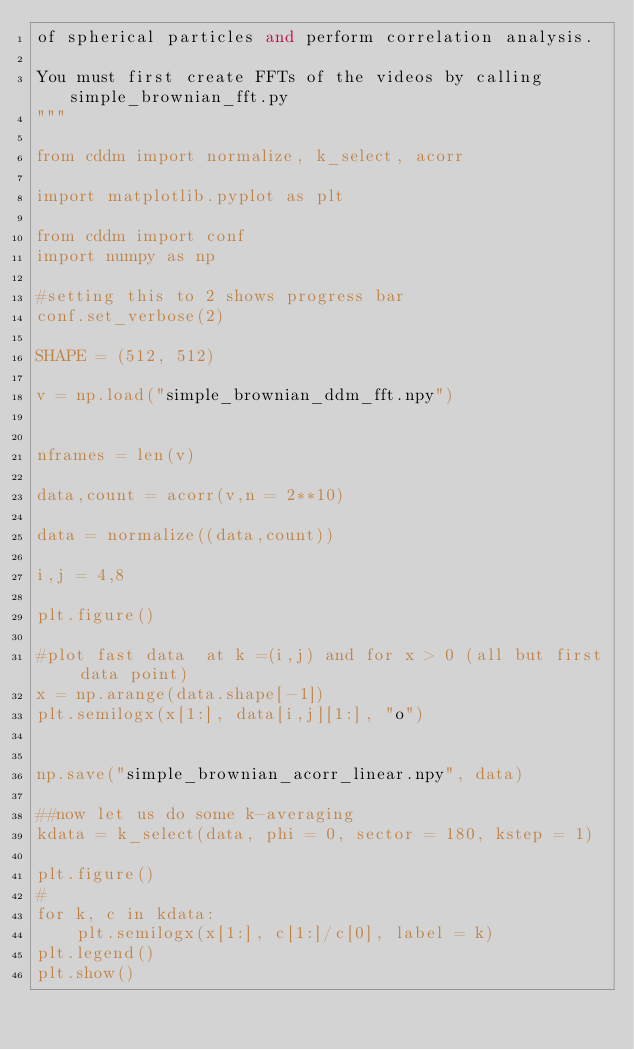Convert code to text. <code><loc_0><loc_0><loc_500><loc_500><_Python_>of spherical particles and perform correlation analysis.

You must first create FFTs of the videos by calling simple_brownian_fft.py
"""

from cddm import normalize, k_select, acorr

import matplotlib.pyplot as plt

from cddm import conf
import numpy as np

#setting this to 2 shows progress bar
conf.set_verbose(2)

SHAPE = (512, 512)

v = np.load("simple_brownian_ddm_fft.npy")


nframes = len(v)

data,count = acorr(v,n = 2**10)

data = normalize((data,count))

i,j = 4,8

plt.figure()

#plot fast data  at k =(i,j) and for x > 0 (all but first data point)
x = np.arange(data.shape[-1])
plt.semilogx(x[1:], data[i,j][1:], "o")


np.save("simple_brownian_acorr_linear.npy", data)

##now let us do some k-averaging
kdata = k_select(data, phi = 0, sector = 180, kstep = 1)

plt.figure()
#
for k, c in kdata: 
    plt.semilogx(x[1:], c[1:]/c[0], label = k)
plt.legend()
plt.show()



</code> 